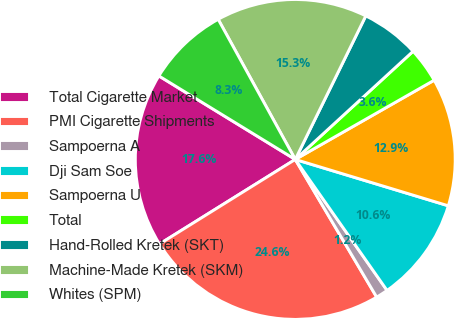Convert chart to OTSL. <chart><loc_0><loc_0><loc_500><loc_500><pie_chart><fcel>Total Cigarette Market<fcel>PMI Cigarette Shipments<fcel>Sampoerna A<fcel>Dji Sam Soe<fcel>Sampoerna U<fcel>Total<fcel>Hand-Rolled Kretek (SKT)<fcel>Machine-Made Kretek (SKM)<fcel>Whites (SPM)<nl><fcel>17.61%<fcel>24.63%<fcel>1.23%<fcel>10.59%<fcel>12.93%<fcel>3.57%<fcel>5.91%<fcel>15.27%<fcel>8.25%<nl></chart> 